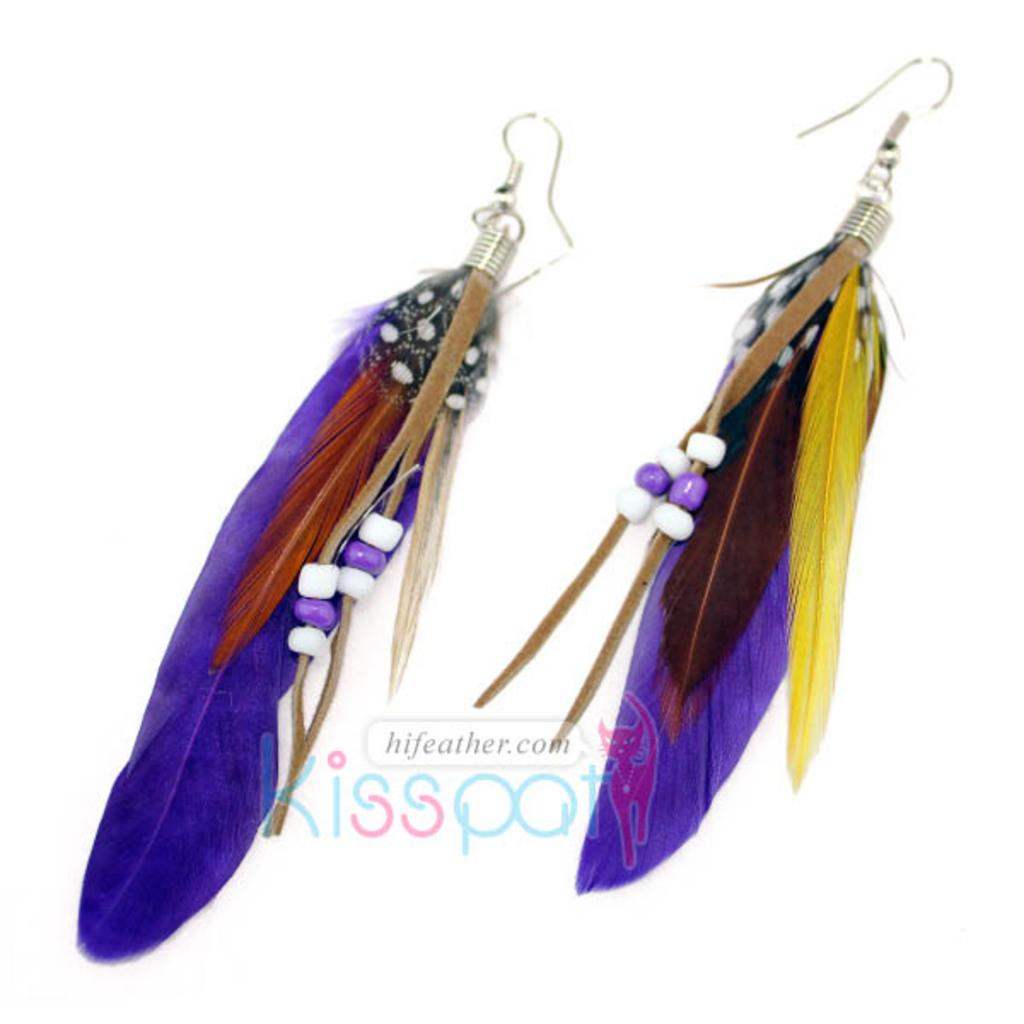What type of accessory is featured in the image? There are two earrings in the image. Can you describe the appearance of the image? The image appears to be edited. What is written at the bottom of the image? There is text at the bottom of the image. What color is the background of the image? The background of the image is white. How many friends are visible in the image? There are no friends visible in the image; it features earrings and text. What type of power source is required for the earrings to function? The earrings are accessories and do not require a power source to function. 